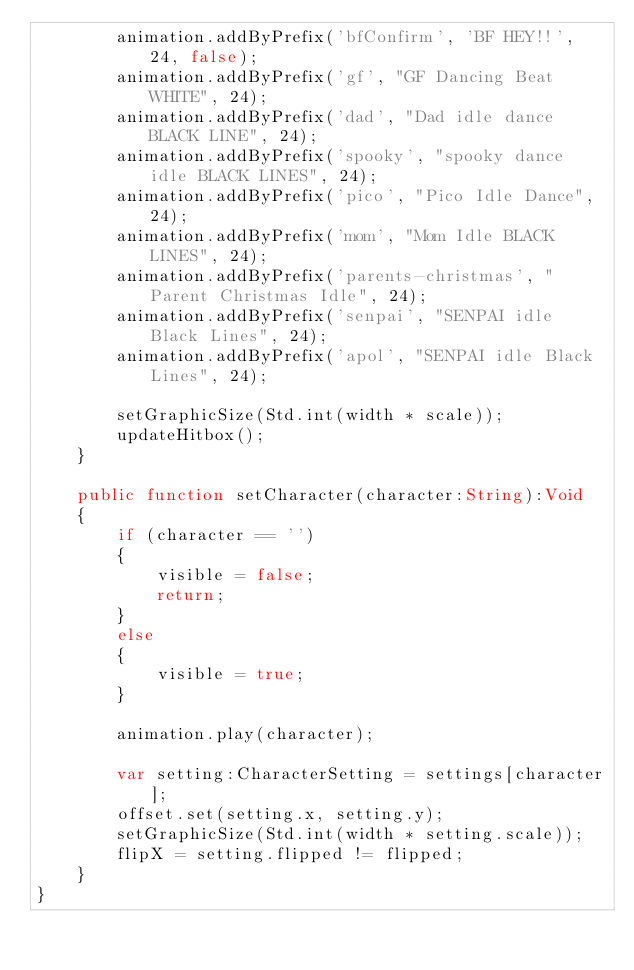<code> <loc_0><loc_0><loc_500><loc_500><_Haxe_>		animation.addByPrefix('bfConfirm', 'BF HEY!!', 24, false);
		animation.addByPrefix('gf', "GF Dancing Beat WHITE", 24);
		animation.addByPrefix('dad', "Dad idle dance BLACK LINE", 24);
		animation.addByPrefix('spooky', "spooky dance idle BLACK LINES", 24);
		animation.addByPrefix('pico', "Pico Idle Dance", 24);
		animation.addByPrefix('mom', "Mom Idle BLACK LINES", 24);
		animation.addByPrefix('parents-christmas', "Parent Christmas Idle", 24);
		animation.addByPrefix('senpai', "SENPAI idle Black Lines", 24);
		animation.addByPrefix('apol', "SENPAI idle Black Lines", 24);

		setGraphicSize(Std.int(width * scale));
		updateHitbox();
	}

	public function setCharacter(character:String):Void
	{
		if (character == '')
		{
			visible = false;
			return;
		}
		else
		{
			visible = true;
		}

		animation.play(character);

		var setting:CharacterSetting = settings[character];
		offset.set(setting.x, setting.y);
		setGraphicSize(Std.int(width * setting.scale));
		flipX = setting.flipped != flipped;
	}
}
</code> 